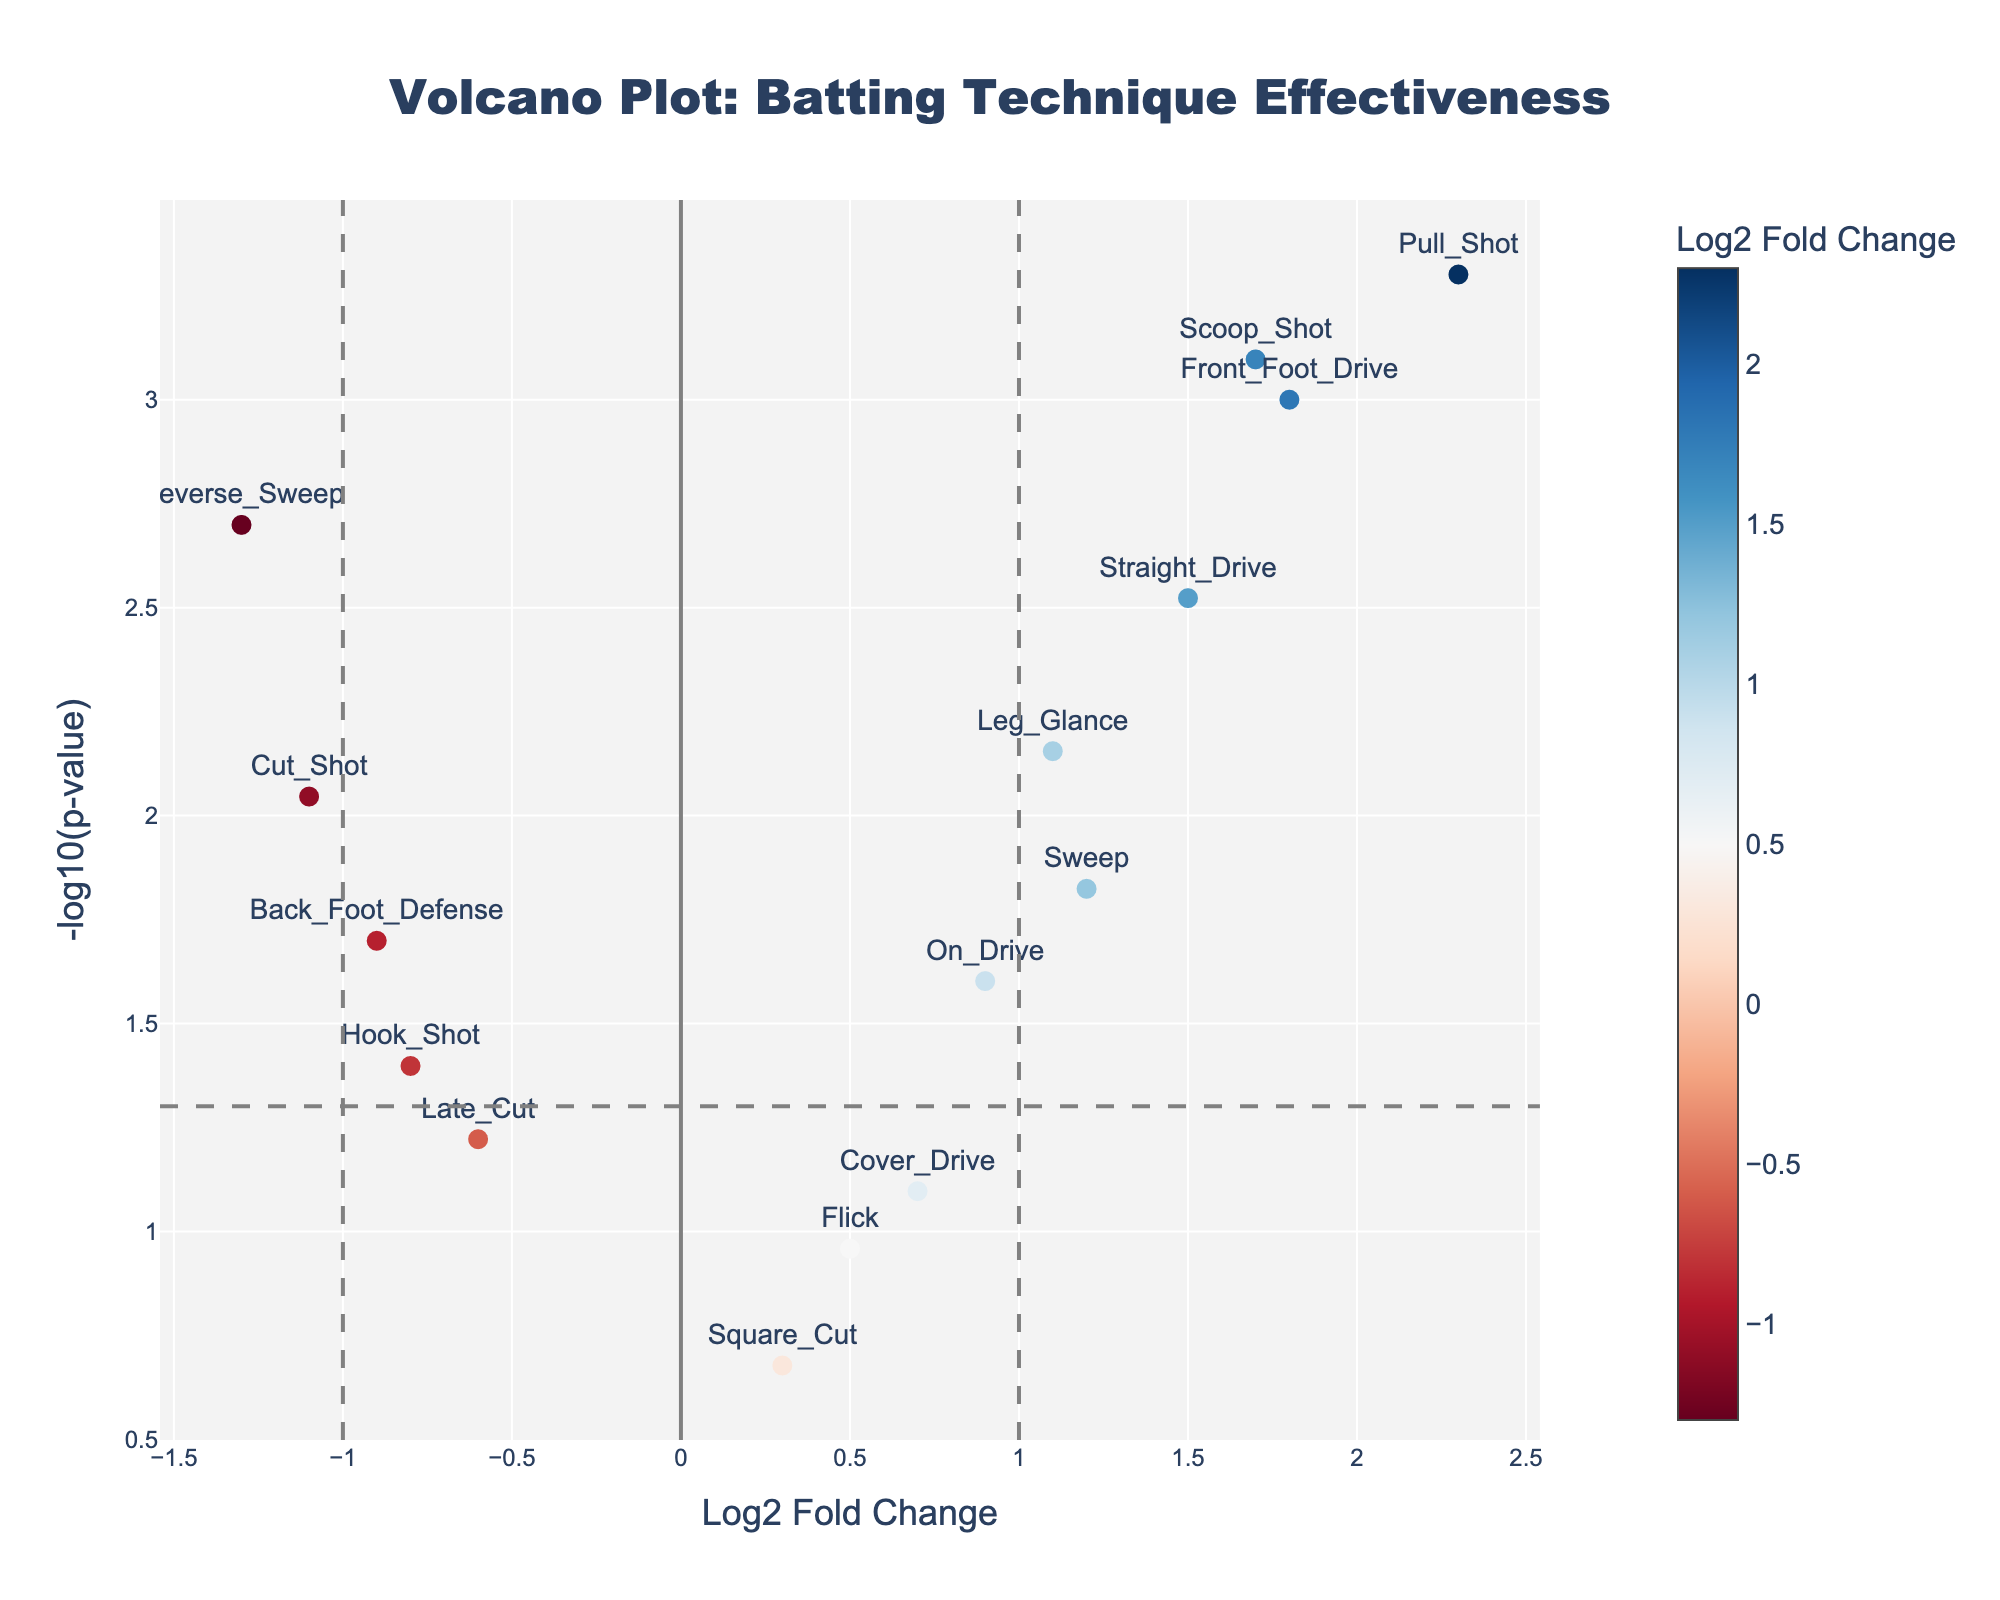What's the title of the plot? The title can be found at the top of the plot.
Answer: Volcano Plot: Batting Technique Effectiveness How many techniques show a statistically significant improvement with Log2 Fold Change above 1? Techniques with p-value less than 0.05 (i.e., -log10(p-value) above the horizontal grey line) and Log2 Fold Change above 1 are counted.
Answer: Three Which batting technique shows the highest improvement? Look for the highest Log2 Fold Change value on the plot.
Answer: Pull Shot What color represents the most significant decline in technique performance? Techniques with a negative Log2 Fold Change and statistically significant p-values will be on the color scale, typically in blue tones.
Answer: Blue What batting technique has a Log2 Fold Change close to zero and is not statistically significant? Examine the techniques near the Log2 Fold Change of 0 line with p-values above 0.05 (below the horizontal grey line).
Answer: Square Cut Is the Cut Shot technique statistically significant? Check if the p-value for Cut Shot is below 0.05 (above the horizontal grey line).
Answer: Yes Compare the effectiveness of Front Foot Drive and Hook Shot. Which technique has shown greater improvement? Compare the Log2 Fold Change values of Front Foot Drive and Hook Shot.
Answer: Front Foot Drive How many batting techniques have a negative Log2 Fold Change and are statistically significant? Count the dots with negative Log2 Fold Change values that lie above the horizontal grey line.
Answer: Three What's the p-value threshold used to determine statistical significance in this figure? The p-value threshold is determined by the horizontal dashed grey line.
Answer: 0.05 Describe the relationship between Log2 Fold Change and p-value in this figure. As the p-value decreases, the -log10(p-value) increases, moving the points upward; higher Log2 Fold Change indicates greater change either positively or negatively.
Answer: Inverse relationship between p-value and -log10(p-value) 